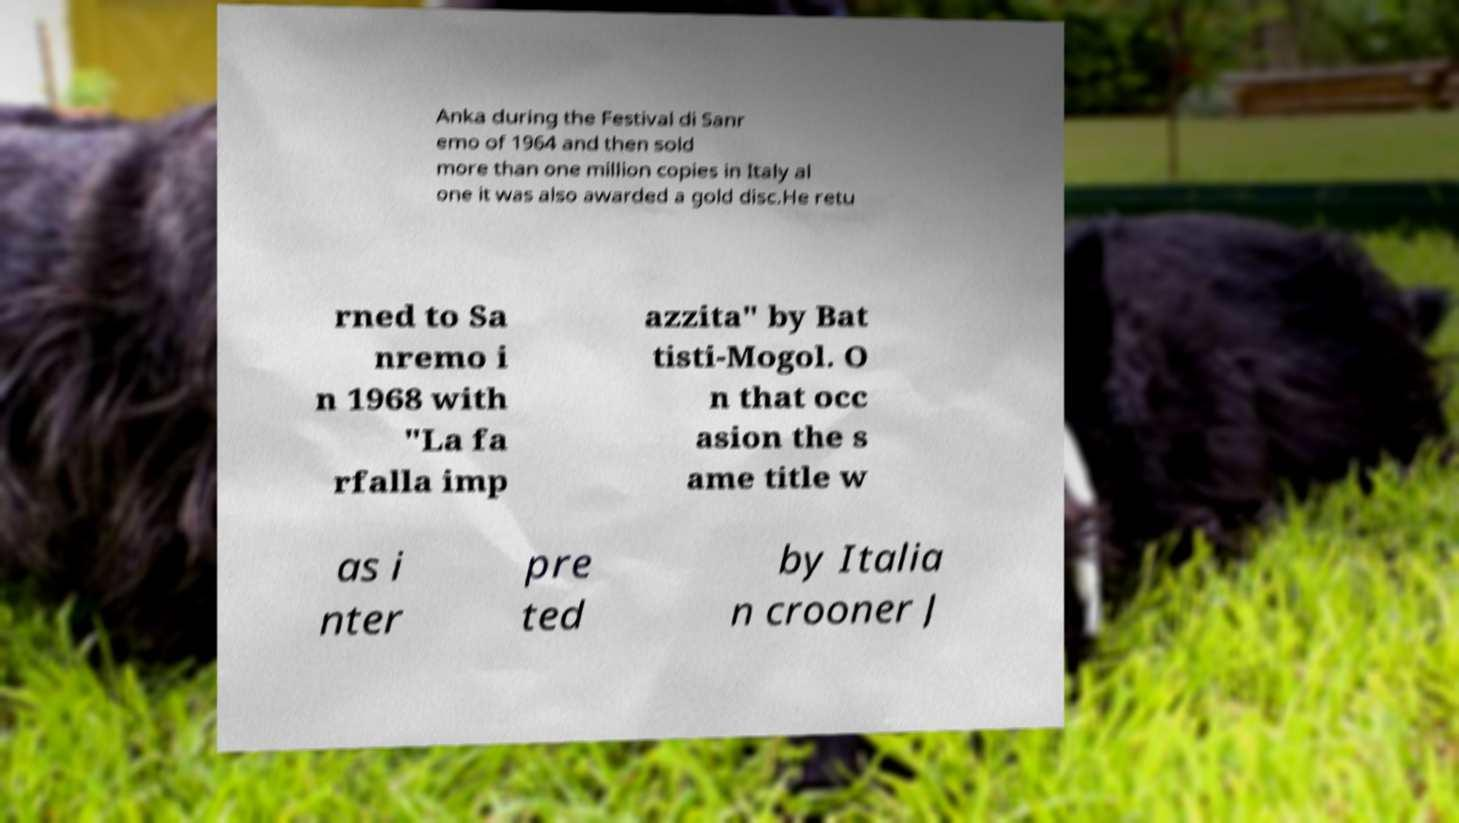Could you assist in decoding the text presented in this image and type it out clearly? Anka during the Festival di Sanr emo of 1964 and then sold more than one million copies in Italy al one it was also awarded a gold disc.He retu rned to Sa nremo i n 1968 with "La fa rfalla imp azzita" by Bat tisti-Mogol. O n that occ asion the s ame title w as i nter pre ted by Italia n crooner J 